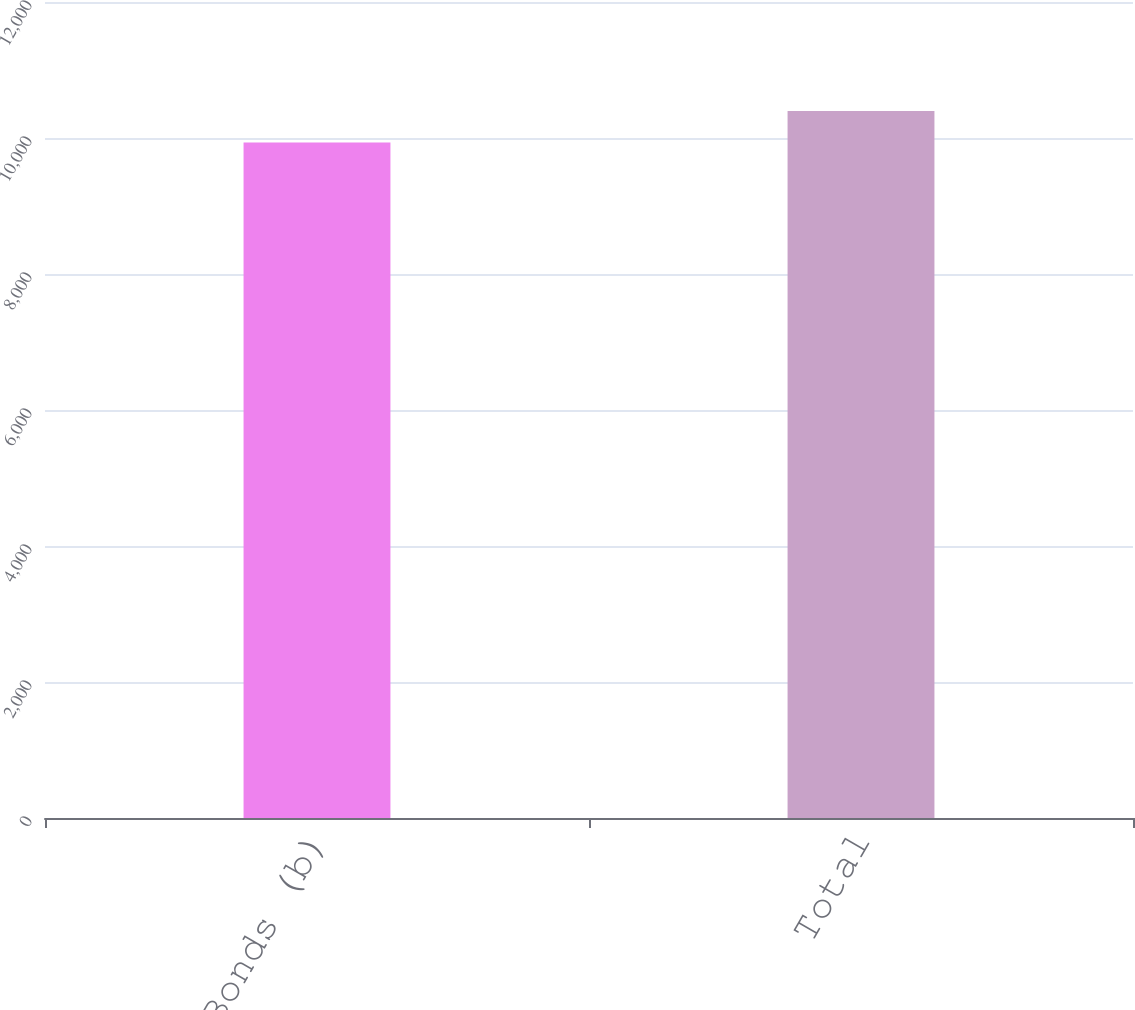<chart> <loc_0><loc_0><loc_500><loc_500><bar_chart><fcel>Bonds (b)<fcel>Total<nl><fcel>9935<fcel>10398<nl></chart> 